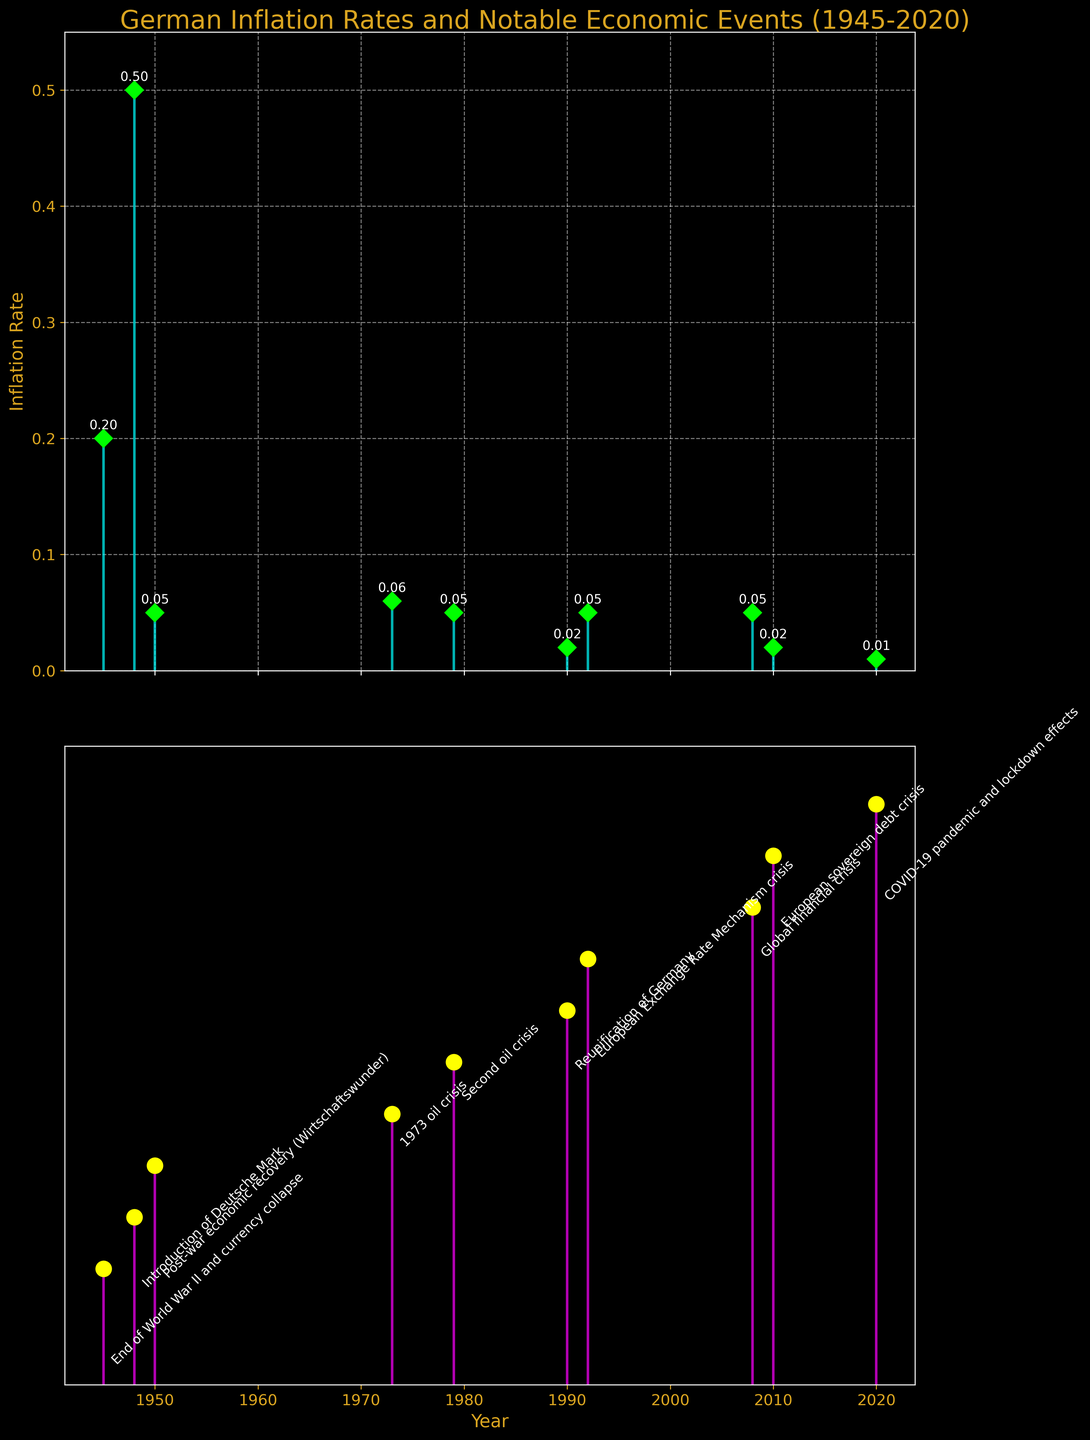What is the title of the figure? The title of the figure is displayed at the top, and it reads "German Inflation Rates and Notable Economic Events (1945-2020)" in goldenrod color, which clearly indicates the scope and subject of the plot.
Answer: German Inflation Rates and Notable Economic Events (1945-2020) What is the maximum inflation rate displayed in the figure, and in which year did it occur? The maximum inflation rate is noted in the stem plot of inflation rates on the first subplot by the highest stem and annotated value, which is 0.50 in the year 1948.
Answer: 0.50 in 1948 Which notable economic event is associated with the lowest inflation rate displayed, and what is the rate? The lowest inflation rate can be identified by the shortest stem on the first subplot, corresponding to the year 2020 with a rate of 0.01, annotated as "COVID-19 pandemic and lockdown effects" in the second subplot.
Answer: COVID-19 pandemic and lockdown effects, 0.01 How did the inflation rate change after the reunification of Germany in 1990? After the reunification of Germany in 1990, where the inflation rate was 0.02, it increased to 0.05 in 1992 according to the stem plot annotations.
Answer: Increased to 0.05 in 1992 Which color represents the marker lines for the inflation rates in the figure? The color of the marker lines for the inflation rates can be identified by their appearance in the first subplot, which is lime.
Answer: Lime What is the difference in inflation rate between the end of World War II (1945) and the second oil crisis (1979)? The inflation rates for the end of World War II (1945) and the second oil crisis (1979) are annotated as 0.20 and 0.05, respectively. The difference is 0.20 - 0.05 = 0.15.
Answer: 0.15 Compare the inflation rates during the two oil crises (1973 and 1979). Which year had a higher rate, and by how much? The inflation rates during the oil crises are annotated as 0.06 for 1973 and 0.05 for 1979 in the first subplot. 1973 had a higher rate, and the difference is 0.06 - 0.05 = 0.01.
Answer: 1973 by 0.01 What general trend can you observe in the inflation rates from 2008 to 2020? Observing the annotated inflation rates from 2008 (0.05), 2010 (0.02), and 2020 (0.01) in the first subplot, there is a general trend of decreasing inflation rates over these years.
Answer: Decreasing trend How many economic events are annotated in the subplots? The number of annotated economic events can be counted from the second subplot, revealing 10 notable economic events listed from 1945 to 2020.
Answer: 10 